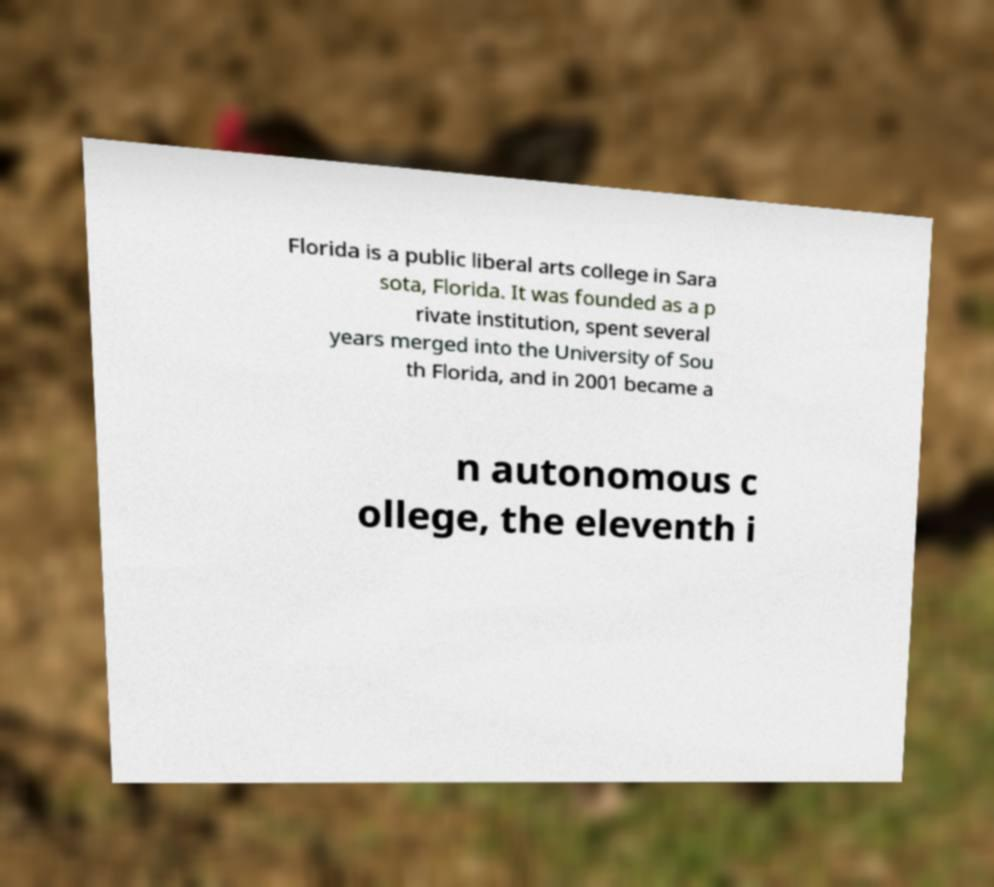Could you assist in decoding the text presented in this image and type it out clearly? Florida is a public liberal arts college in Sara sota, Florida. It was founded as a p rivate institution, spent several years merged into the University of Sou th Florida, and in 2001 became a n autonomous c ollege, the eleventh i 